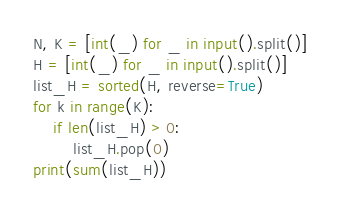Convert code to text. <code><loc_0><loc_0><loc_500><loc_500><_Python_>N, K = [int(_) for _ in input().split()]
H = [int(_) for _ in input().split()]
list_H = sorted(H, reverse=True)
for k in range(K):
    if len(list_H) > 0:
        list_H.pop(0)
print(sum(list_H))
</code> 